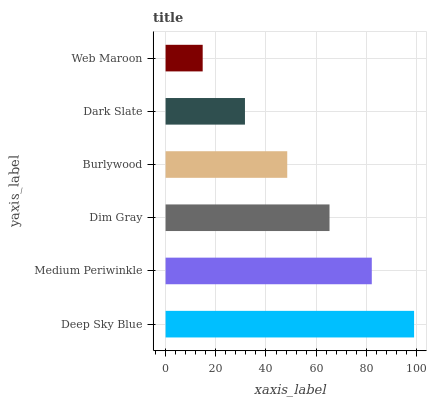Is Web Maroon the minimum?
Answer yes or no. Yes. Is Deep Sky Blue the maximum?
Answer yes or no. Yes. Is Medium Periwinkle the minimum?
Answer yes or no. No. Is Medium Periwinkle the maximum?
Answer yes or no. No. Is Deep Sky Blue greater than Medium Periwinkle?
Answer yes or no. Yes. Is Medium Periwinkle less than Deep Sky Blue?
Answer yes or no. Yes. Is Medium Periwinkle greater than Deep Sky Blue?
Answer yes or no. No. Is Deep Sky Blue less than Medium Periwinkle?
Answer yes or no. No. Is Dim Gray the high median?
Answer yes or no. Yes. Is Burlywood the low median?
Answer yes or no. Yes. Is Burlywood the high median?
Answer yes or no. No. Is Deep Sky Blue the low median?
Answer yes or no. No. 